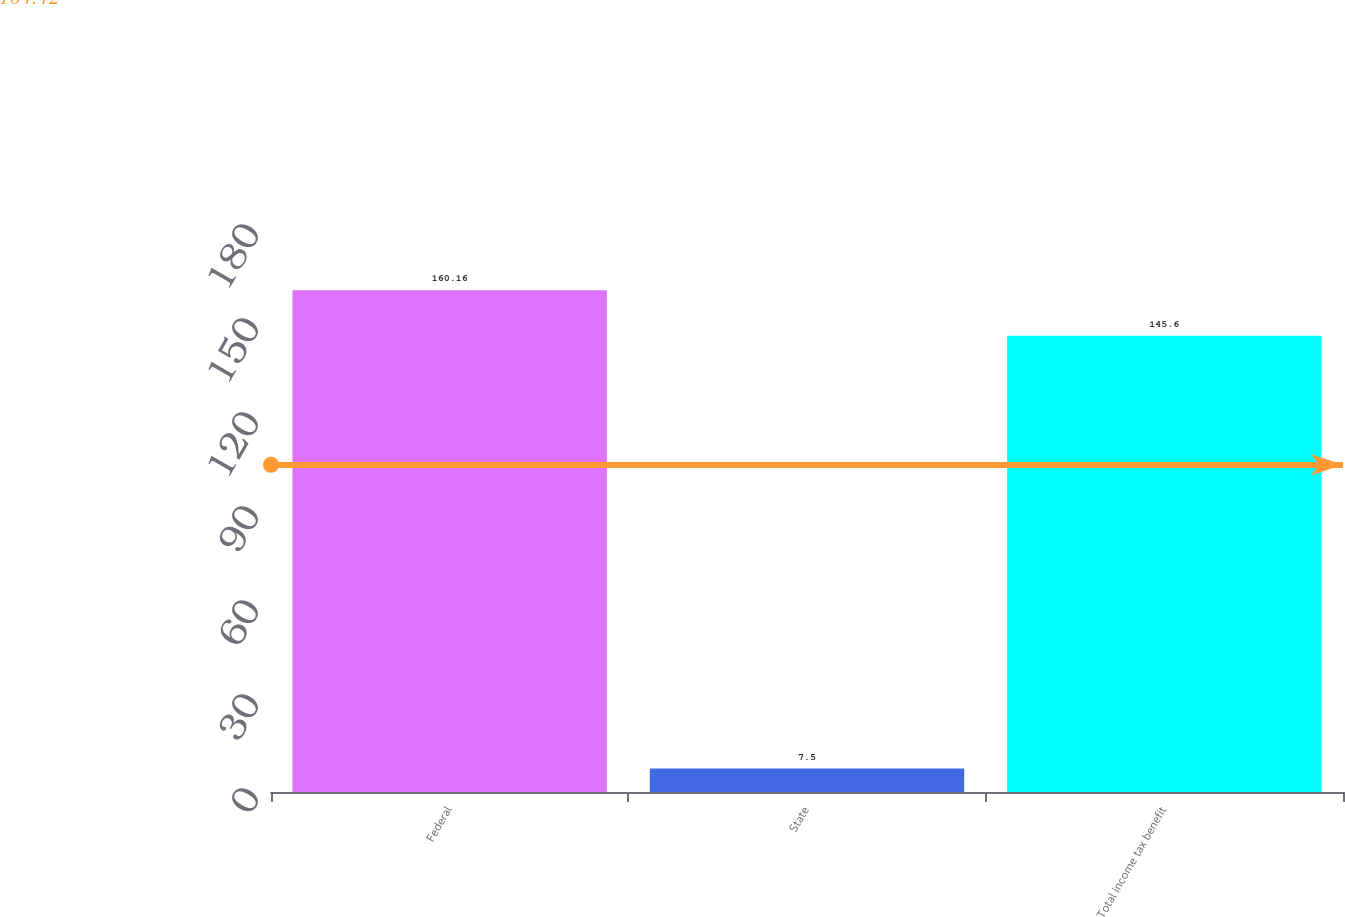Convert chart to OTSL. <chart><loc_0><loc_0><loc_500><loc_500><bar_chart><fcel>Federal<fcel>State<fcel>Total income tax benefit<nl><fcel>160.16<fcel>7.5<fcel>145.6<nl></chart> 